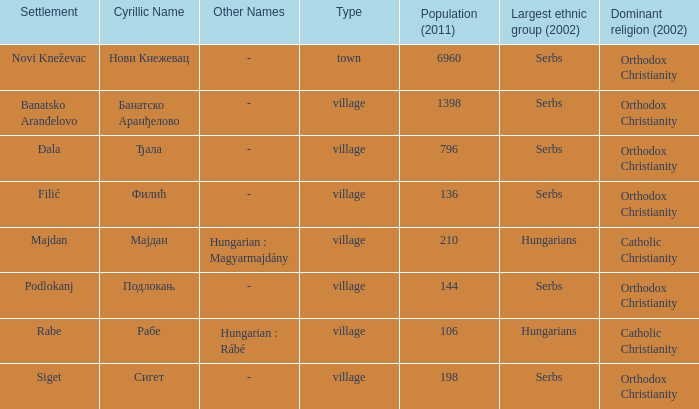How many dominant religions are in đala? 1.0. 